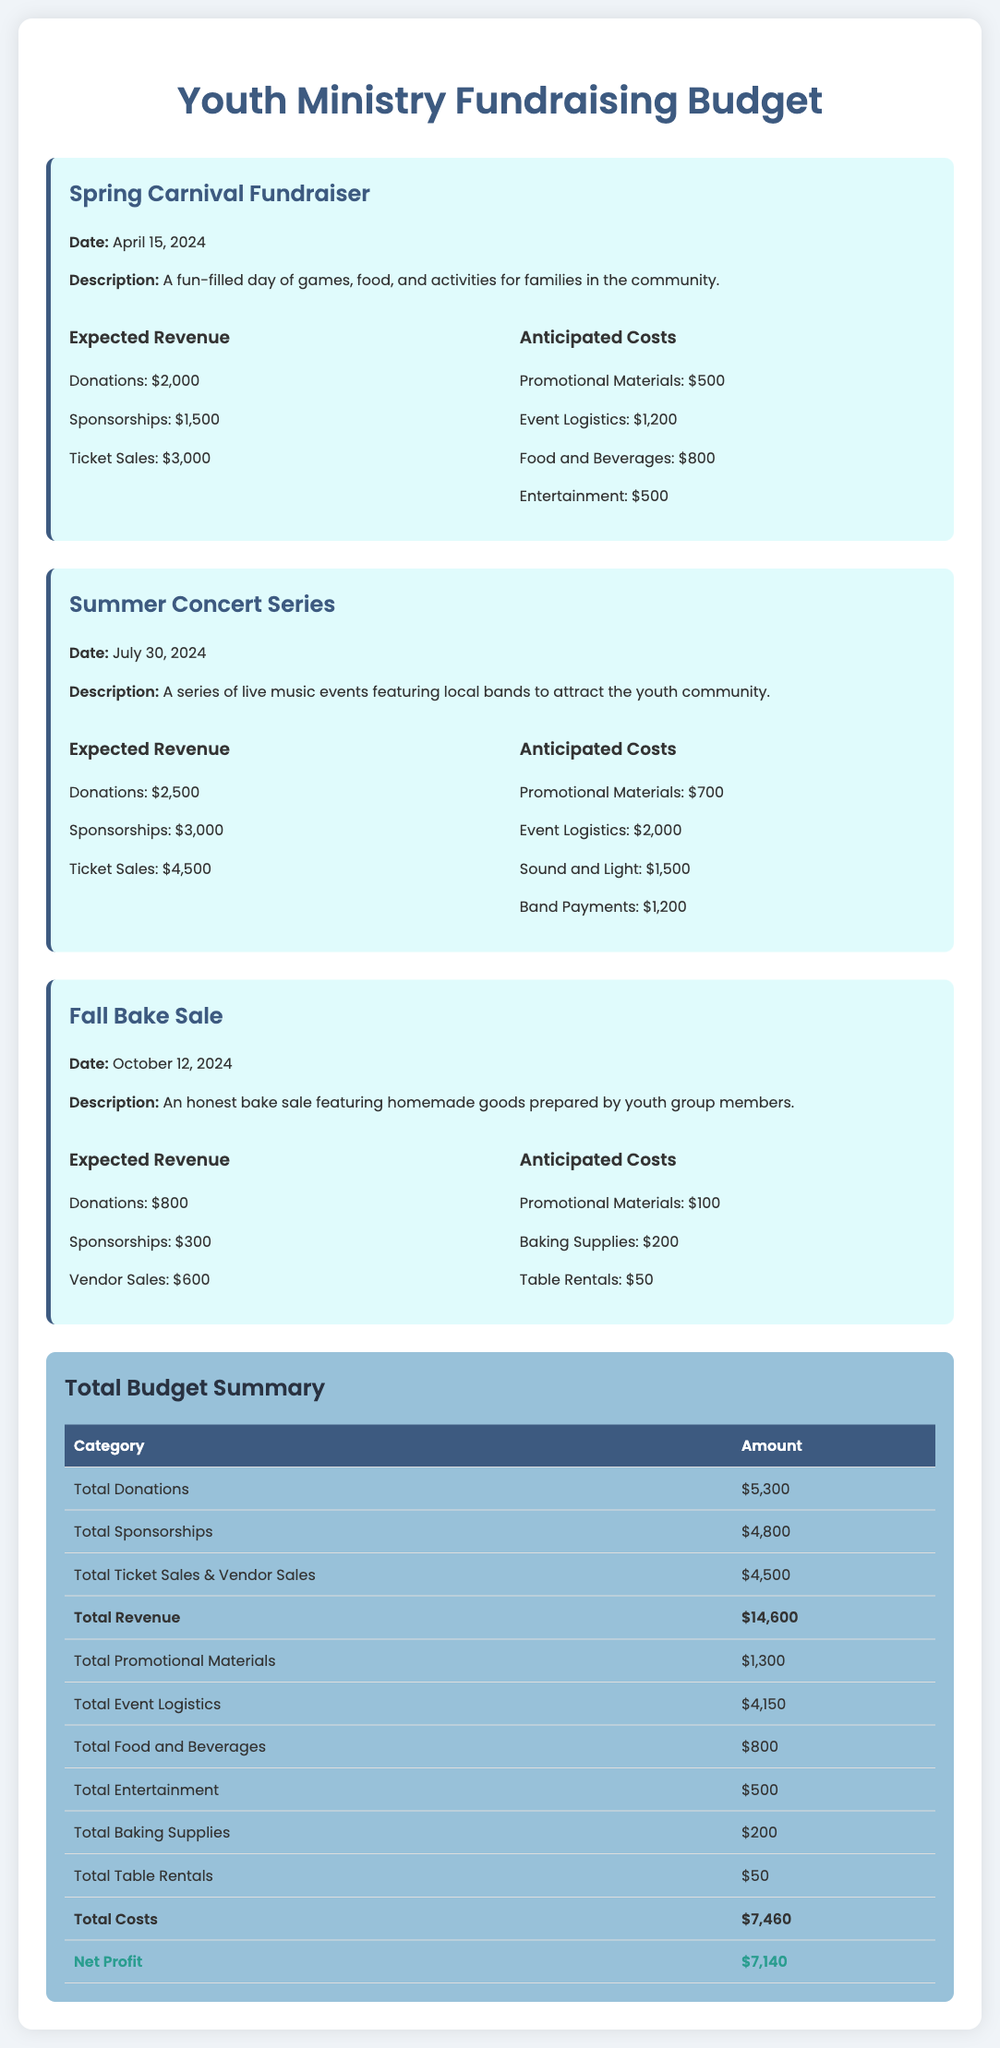what is the date of the Spring Carnival Fundraiser? The date is explicitly stated in the document under the Spring Carnival Fundraiser section.
Answer: April 15, 2024 how much is expected from ticket sales in the Summer Concert Series? The ticket sales amount for the Summer Concert Series is directly provided in that section of the document.
Answer: $4,500 what are the total anticipated costs for the Fall Bake Sale? The total anticipated costs can be calculated by adding all costs given for the Fall Bake Sale. The sum totals to $350.
Answer: $350 which event has the highest expected revenue from donations? By comparing the donations listed under each event, the one with the highest donations can be identified.
Answer: Summer Concert Series what is the net profit of all fundraising initiatives combined? The net profit is provided as the final calculation in the Total Budget Summary section.
Answer: $7,140 how much was allocated for promotional materials across all events? The promotional materials cost is listed separately for each event, and the total is found by summing these amounts.
Answer: $1,300 what kind of entertainment is planned for the Spring Carnival Fundraiser? The types of entertainment are listed under the anticipated costs for the Spring Carnival Fundraiser section.
Answer: Entertainment what is the total revenue generated from sponsorships? Total expected revenue from sponsorships is provided by summing the amounts listed for each event.
Answer: $4,800 which event description mentions homemade goods? The description for the event is mentioned in the Fall Bake Sale section of the document.
Answer: Fall Bake Sale 